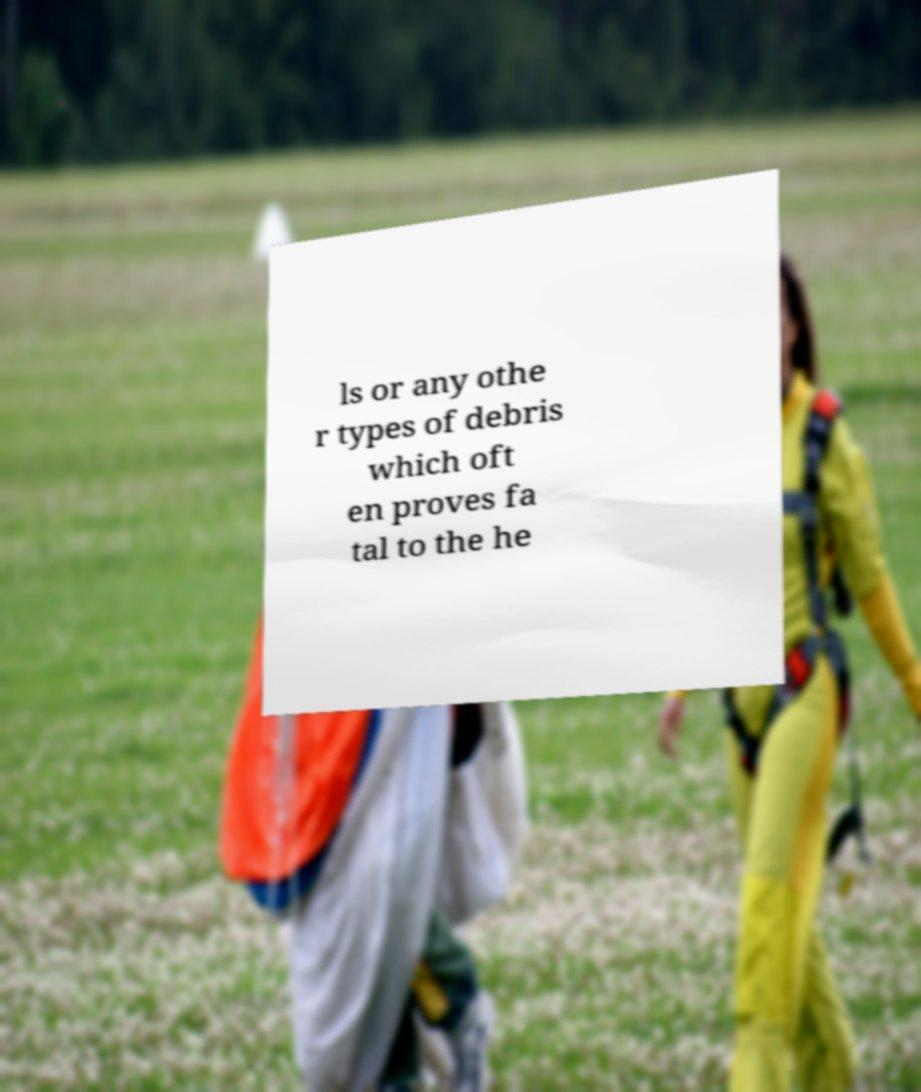Can you accurately transcribe the text from the provided image for me? ls or any othe r types of debris which oft en proves fa tal to the he 